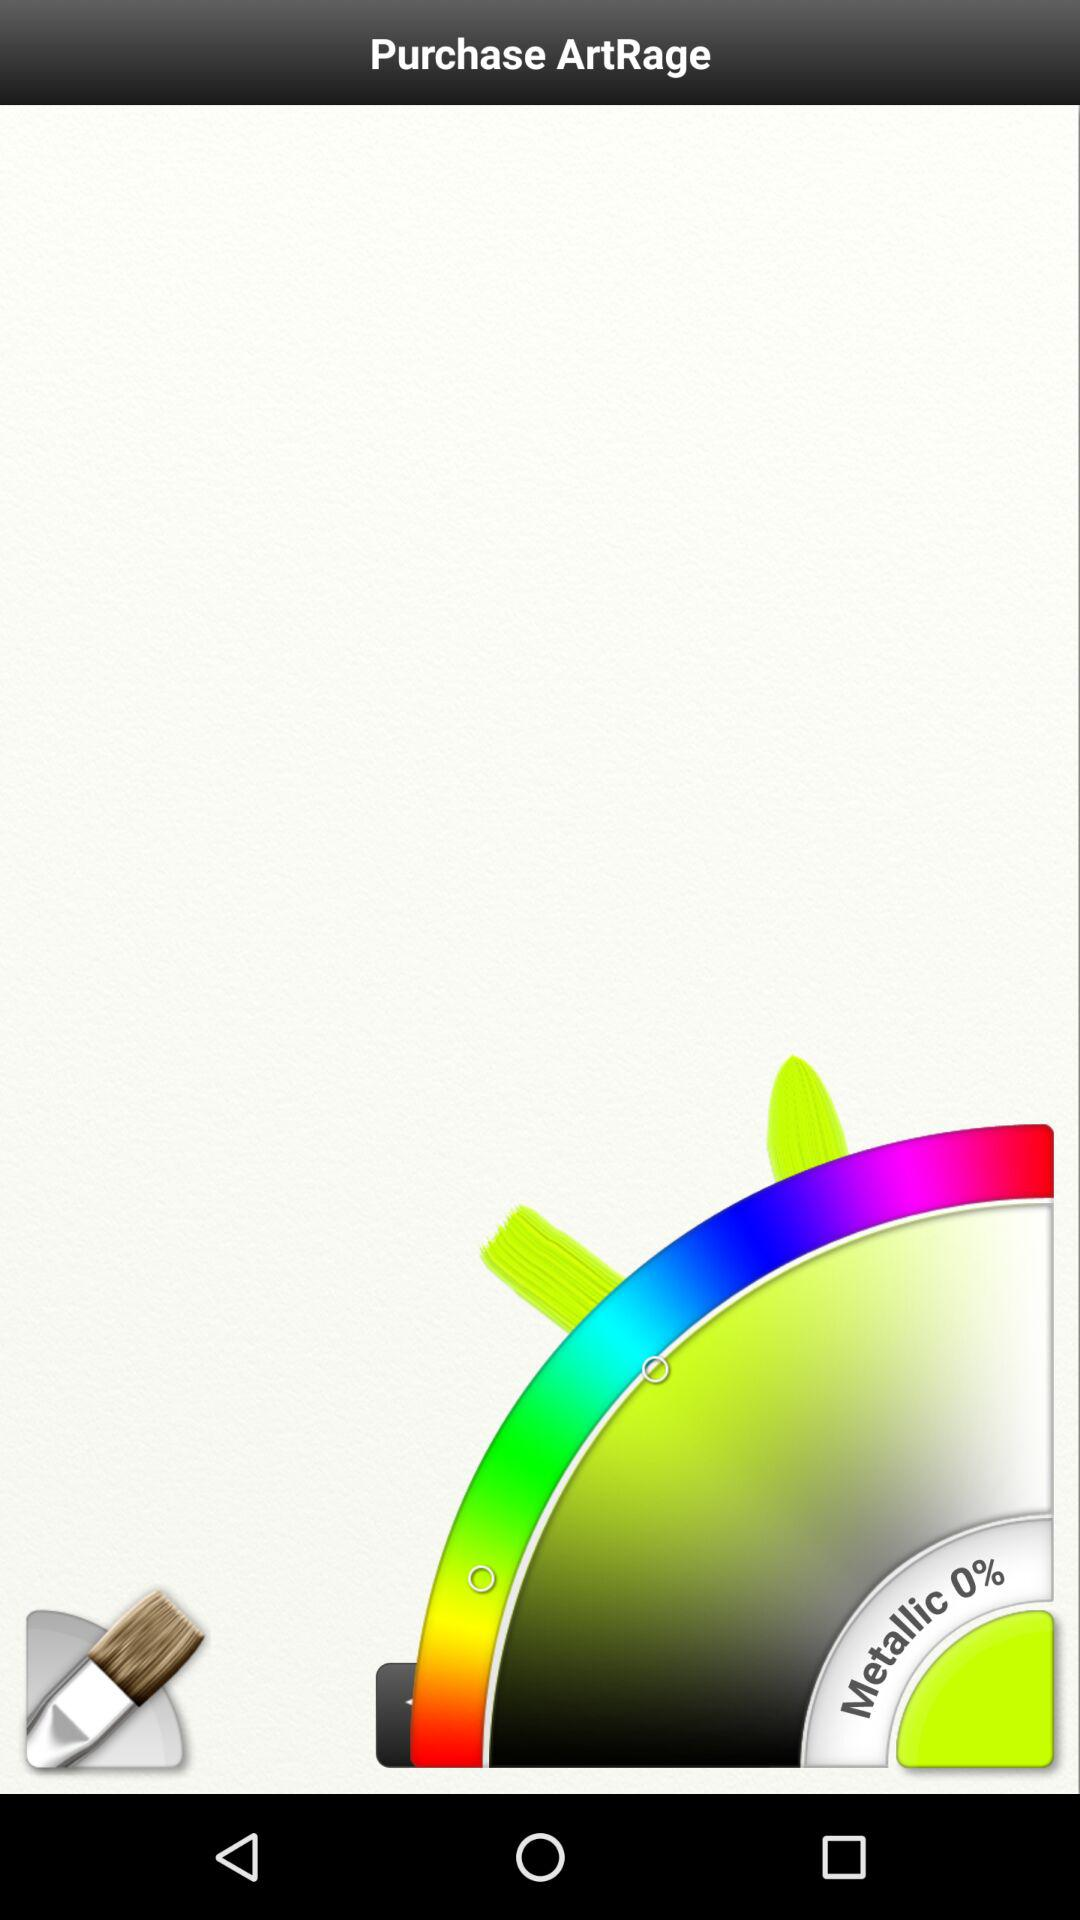What is the application name? The application name is "ArtRage". 